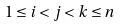<formula> <loc_0><loc_0><loc_500><loc_500>1 \leq i < j < k \leq n</formula> 